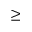Convert formula to latex. <formula><loc_0><loc_0><loc_500><loc_500>\geq</formula> 